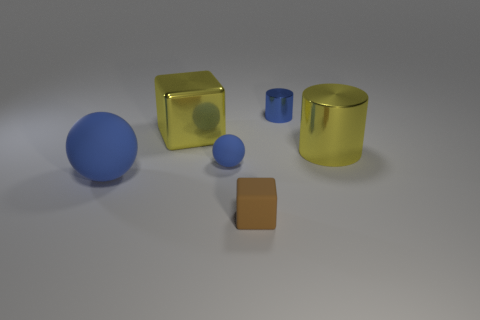How many blue spheres must be subtracted to get 1 blue spheres? 1 Add 1 shiny blocks. How many objects exist? 7 Subtract 0 purple cubes. How many objects are left? 6 Subtract all spheres. How many objects are left? 4 Subtract 1 cylinders. How many cylinders are left? 1 Subtract all yellow blocks. Subtract all red balls. How many blocks are left? 1 Subtract all gray cylinders. How many brown spheres are left? 0 Subtract all small cylinders. Subtract all yellow things. How many objects are left? 3 Add 1 small metallic things. How many small metallic things are left? 2 Add 3 tiny cylinders. How many tiny cylinders exist? 4 